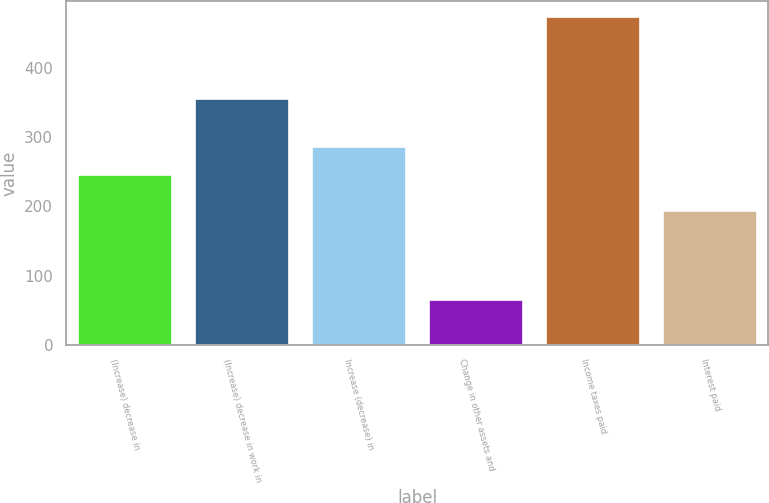Convert chart. <chart><loc_0><loc_0><loc_500><loc_500><bar_chart><fcel>(Increase) decrease in<fcel>(Increase) decrease in work in<fcel>Increase (decrease) in<fcel>Change in other assets and<fcel>Income taxes paid<fcel>Interest paid<nl><fcel>244.8<fcel>354.5<fcel>285.55<fcel>64.9<fcel>472.4<fcel>192.8<nl></chart> 